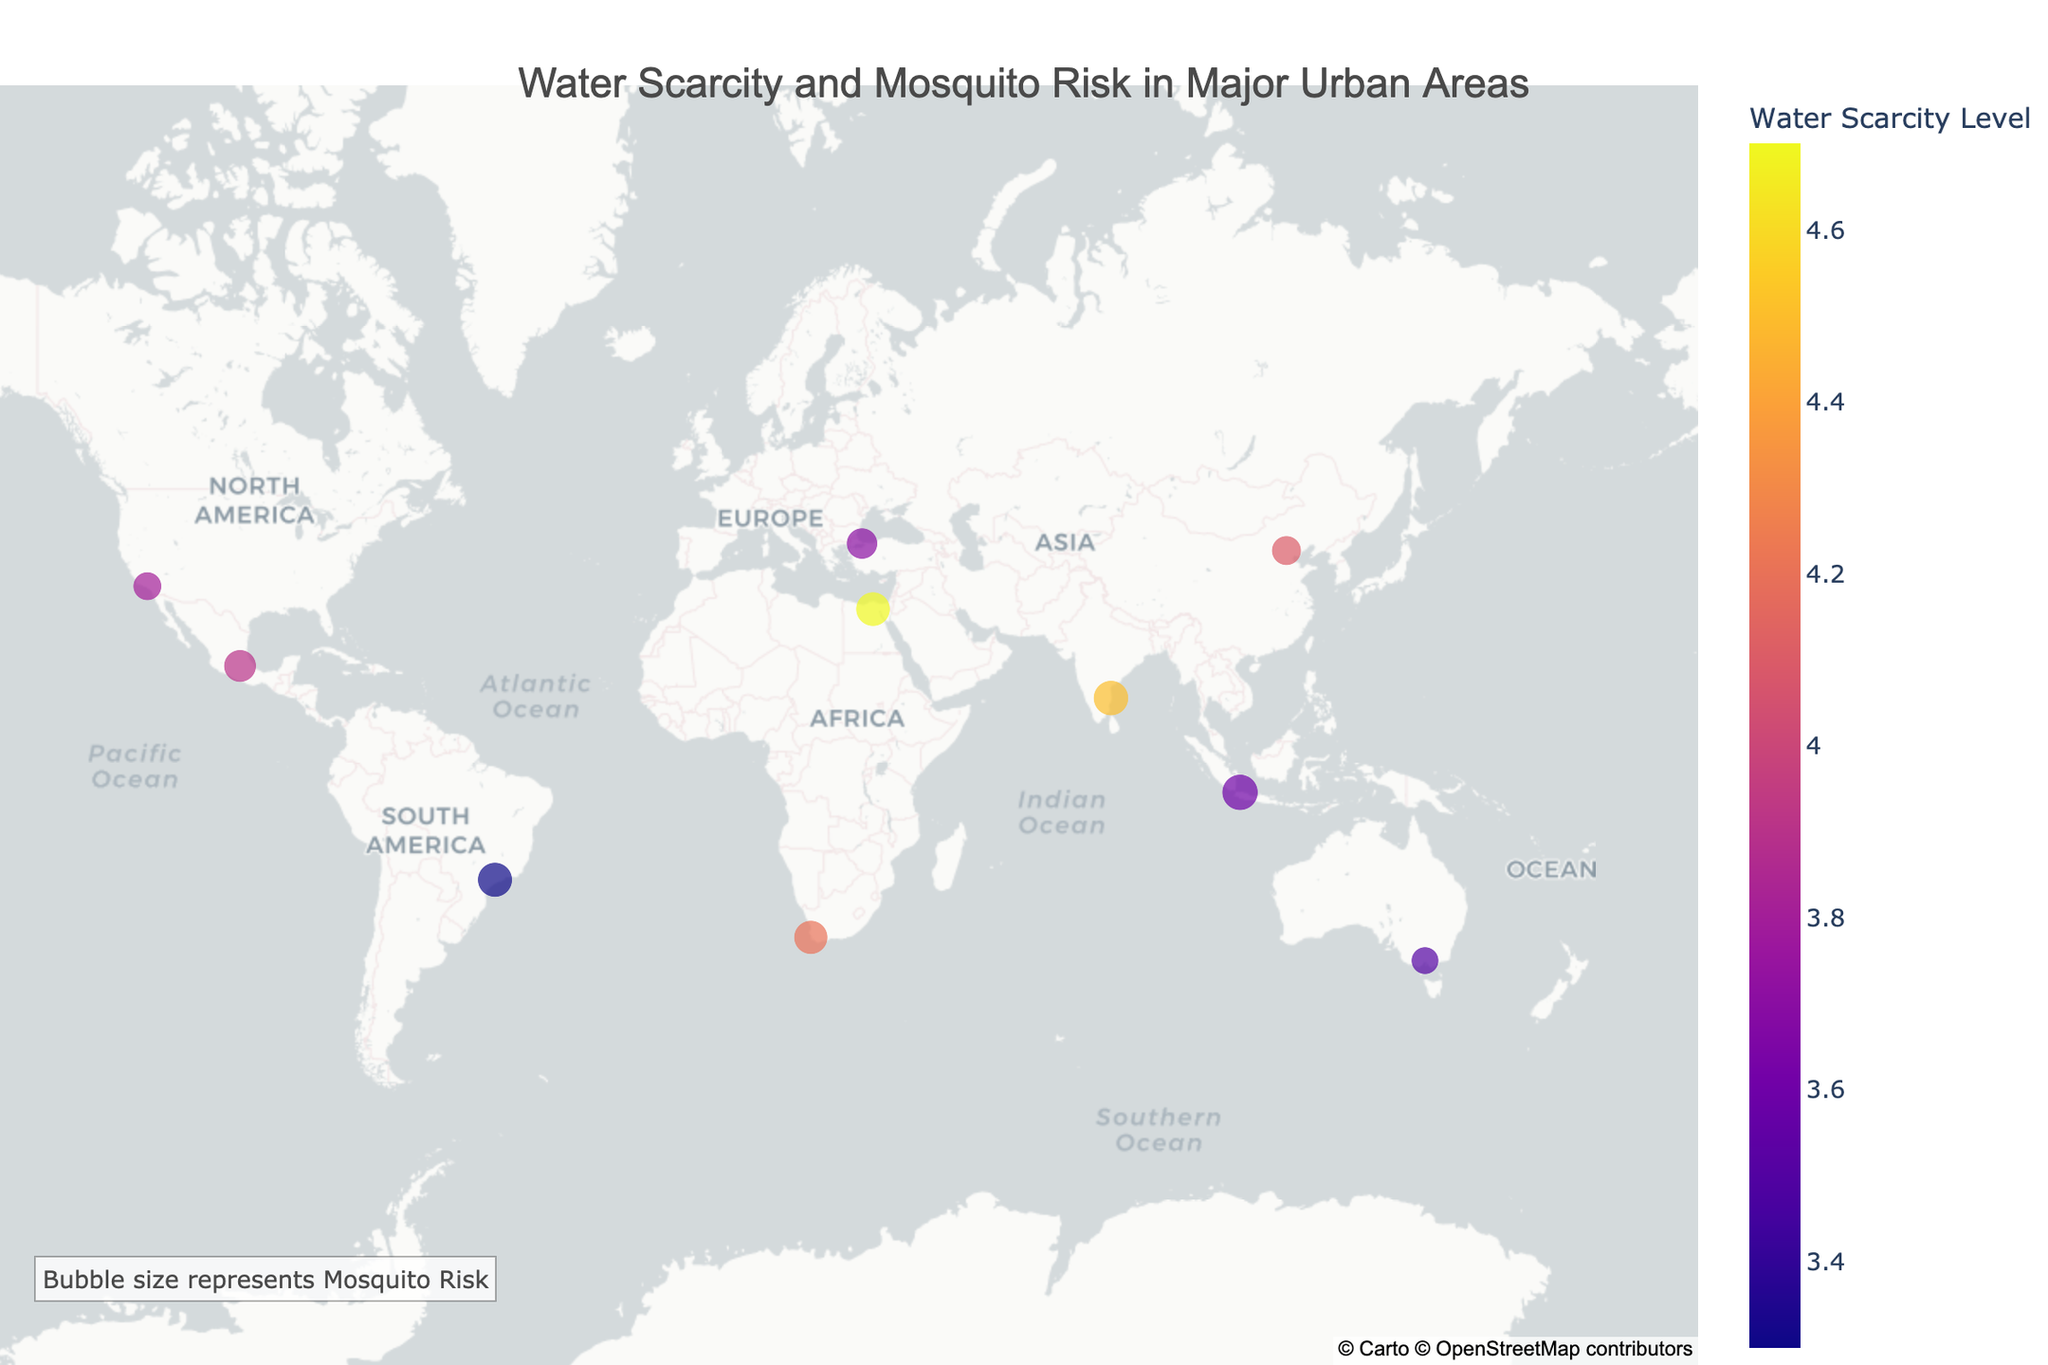What is the title of the plot? The title is displayed at the top center of the plot, it reads "Water Scarcity and Mosquito Risk in Major Urban Areas".
Answer: Water Scarcity and Mosquito Risk in Major Urban Areas Which city has the highest water scarcity level? By inspecting the color gradient on the map, we find that Cairo has the darkest color, indicating the highest water scarcity level of 4.7.
Answer: Cairo Which cities have a mosquito risk level higher than 4.0? From the bubble sizes, we see that Jakarta and Chennai have mosquito risk levels above 4.0, with Jakarta at 4.3 and Chennai at 4.1.
Answer: Jakarta, Chennai Which city has the largest bubble size and what does it represent? The largest bubble size corresponds to Jakarta, indicating the highest mosquito risk level of 4.3.
Answer: Jakarta Compare the water scarcity levels between Cape Town and Istanbul. Which city has a higher level? Checking the colors representing Cape Town and Istanbul, Cape Town has a darker color, indicating a higher water scarcity level of 4.2 compared to Istanbul's 3.7.
Answer: Cape Town What is the average water scarcity level of all the cities displayed? The water scarcity levels are 4.2, 4.5, 3.9, 4.7, 3.6, 3.3, 3.8, 4.1, 3.5, and 3.7. Summing these gives 39.3. Dividing by the number of cities (10), the average is 39.3/10 = 3.93.
Answer: 3.93 Which cities are in the Southern Hemisphere and what are their mosquito risks? Cape Town, Jakarta, Sao Paulo, and Melbourne are located in the Southern Hemisphere as determined by their negative latitudes. Their mosquito risks are 3.8, 4.3, 4.0, and 2.5 respectively.
Answer: Cape Town (3.8), Jakarta (4.3), Sao Paulo (4.0), Melbourne (2.5) Which city has the lowest mosquito risk and what is its water scarcity level? The smallest bubble size on the map corresponds to Melbourne, indicating the lowest mosquito risk of 2.5. Melbourne's water scarcity level is 3.5.
Answer: Melbourne (2.5, 3.5) Between Mexico City and Los Angeles, which city has a higher mosquito risk? Comparing the bubbles for Mexico City and Los Angeles, we find that Mexico City has a mosquito risk of 3.5, which is higher than Los Angeles's 2.7.
Answer: Mexico City 